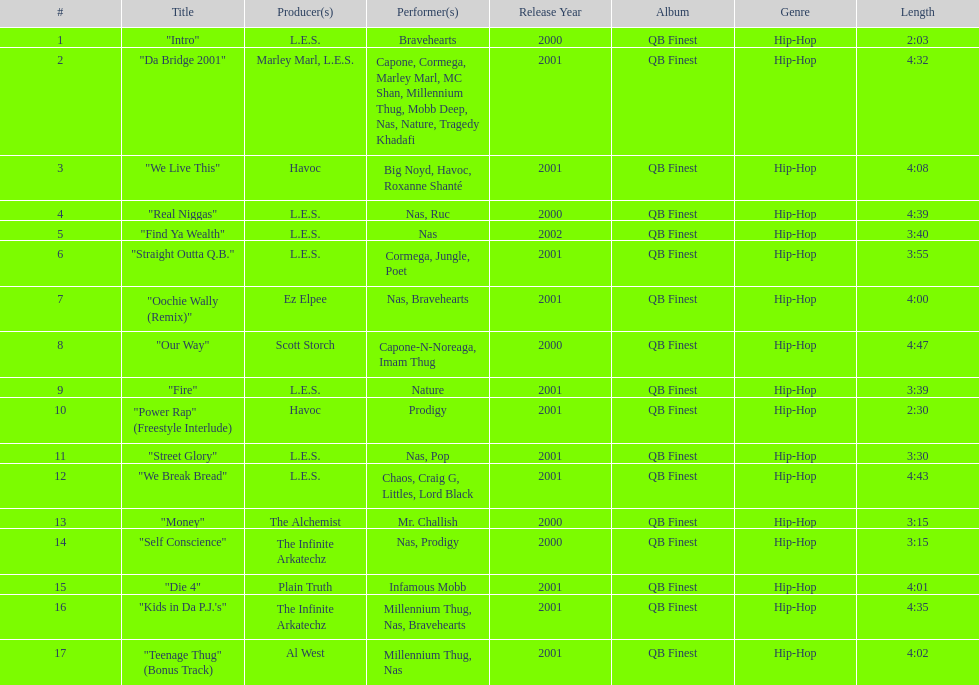How many songs are at least 4 minutes long? 9. 